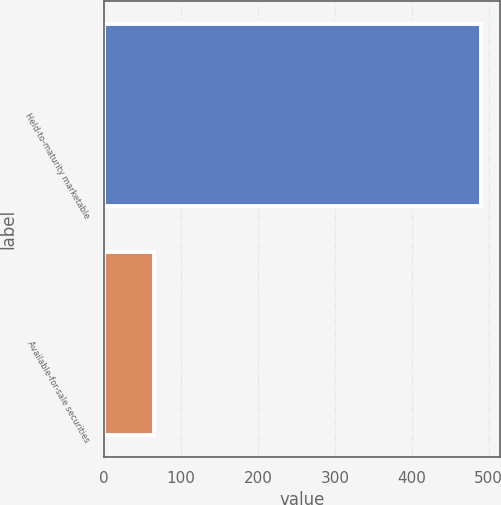<chart> <loc_0><loc_0><loc_500><loc_500><bar_chart><fcel>Held-to-maturity marketable<fcel>Available-for-sale securities<nl><fcel>490<fcel>65<nl></chart> 